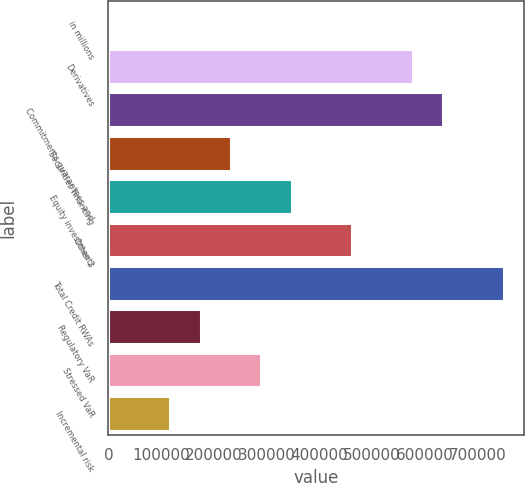<chart> <loc_0><loc_0><loc_500><loc_500><bar_chart><fcel>in millions<fcel>Derivatives<fcel>Commitments guarantees and<fcel>Securities financing<fcel>Equity investments<fcel>Other 2<fcel>Total Credit RWAs<fcel>Regulatory VaR<fcel>Stressed VaR<fcel>Incremental risk<nl><fcel>2015<fcel>577651<fcel>635215<fcel>232269<fcel>347397<fcel>462524<fcel>750342<fcel>174706<fcel>289833<fcel>117142<nl></chart> 